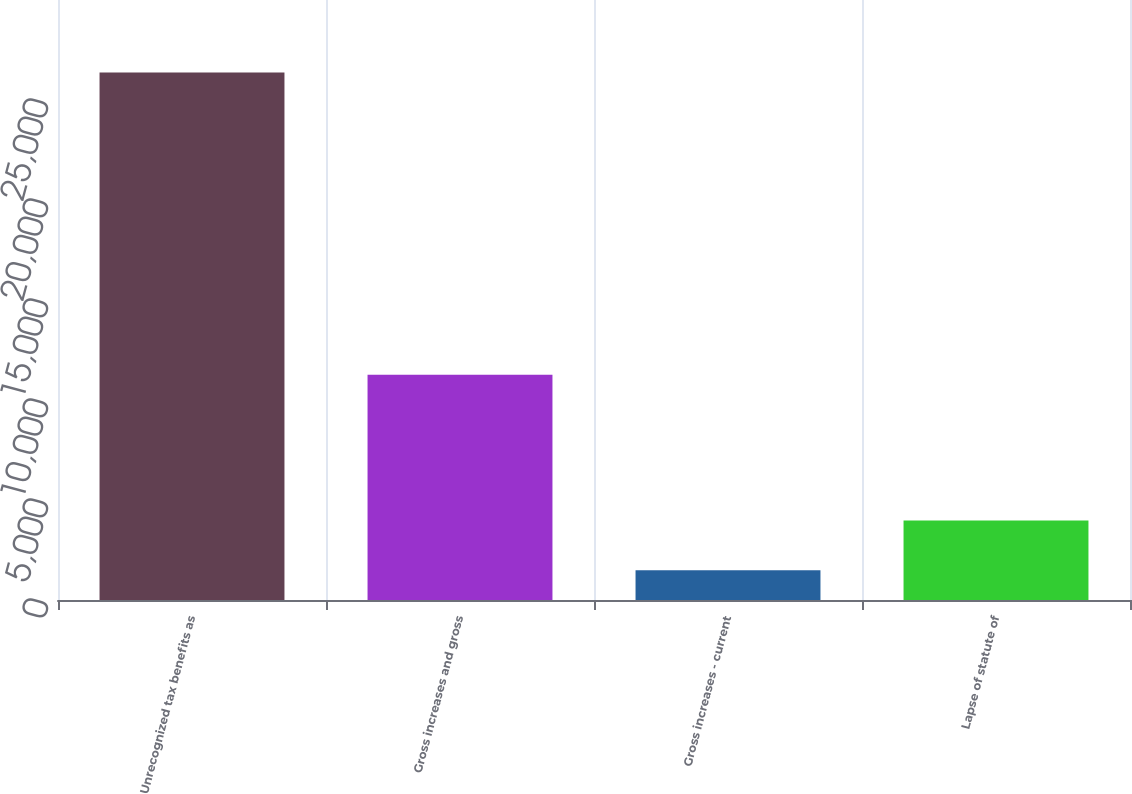Convert chart to OTSL. <chart><loc_0><loc_0><loc_500><loc_500><bar_chart><fcel>Unrecognized tax benefits as<fcel>Gross increases and gross<fcel>Gross increases - current<fcel>Lapse of statute of<nl><fcel>26381<fcel>11268<fcel>1483<fcel>3972.8<nl></chart> 